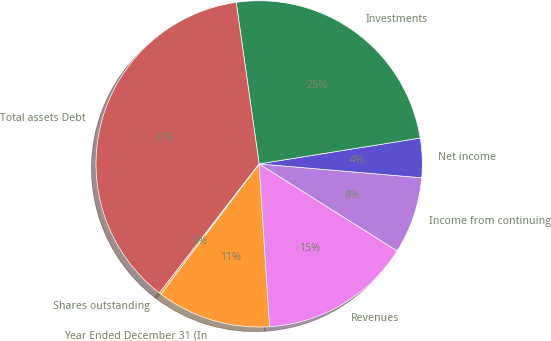<chart> <loc_0><loc_0><loc_500><loc_500><pie_chart><fcel>Year Ended December 31 (In<fcel>Revenues<fcel>Income from continuing<fcel>Net income<fcel>Investments<fcel>Total assets Debt<fcel>Shares outstanding<nl><fcel>11.31%<fcel>15.02%<fcel>7.6%<fcel>3.89%<fcel>24.71%<fcel>37.28%<fcel>0.18%<nl></chart> 